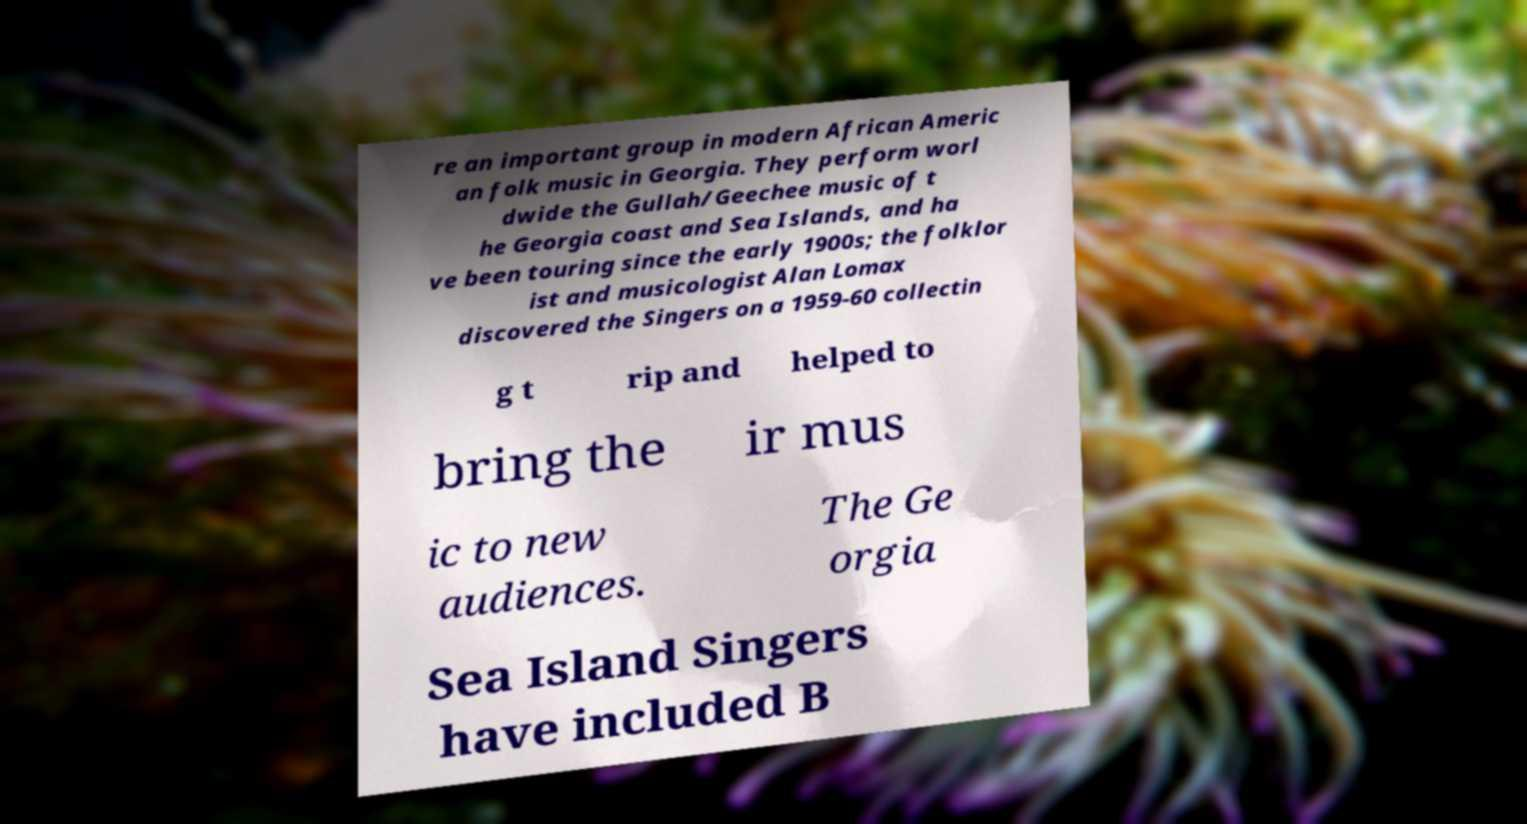For documentation purposes, I need the text within this image transcribed. Could you provide that? re an important group in modern African Americ an folk music in Georgia. They perform worl dwide the Gullah/Geechee music of t he Georgia coast and Sea Islands, and ha ve been touring since the early 1900s; the folklor ist and musicologist Alan Lomax discovered the Singers on a 1959-60 collectin g t rip and helped to bring the ir mus ic to new audiences. The Ge orgia Sea Island Singers have included B 